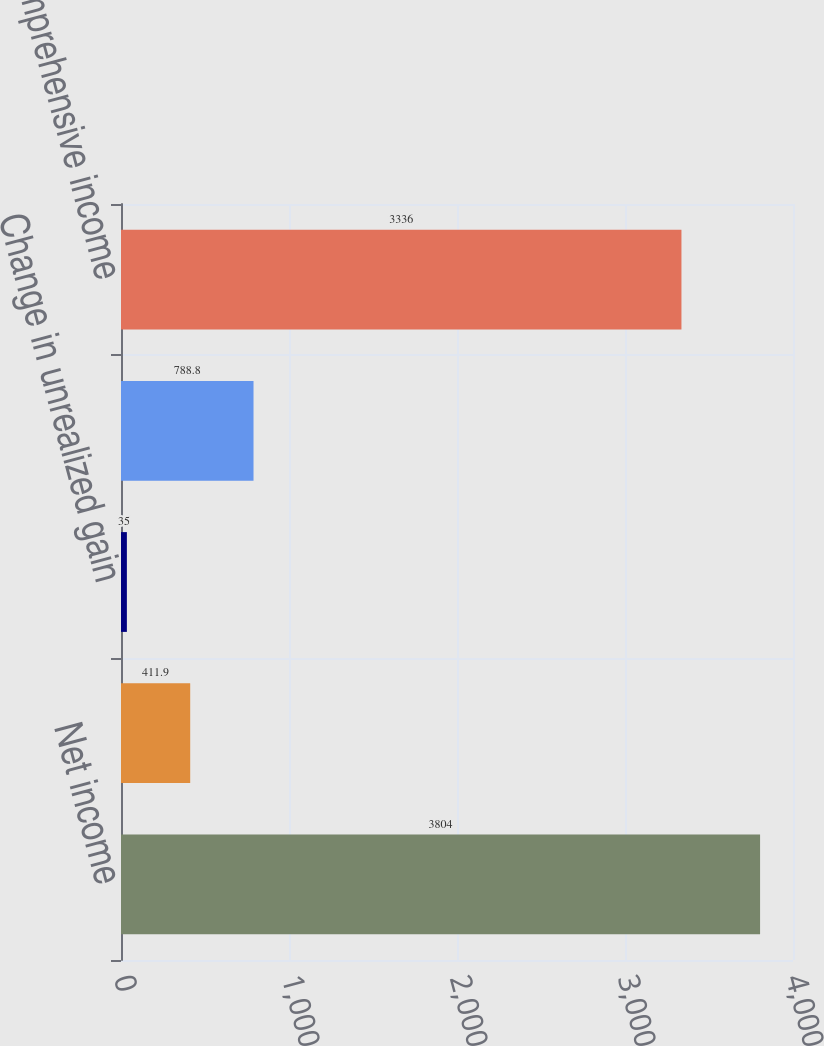Convert chart to OTSL. <chart><loc_0><loc_0><loc_500><loc_500><bar_chart><fcel>Net income<fcel>Change in foreign currency<fcel>Change in unrealized gain<fcel>Change in unrecognized pension<fcel>Comprehensive income<nl><fcel>3804<fcel>411.9<fcel>35<fcel>788.8<fcel>3336<nl></chart> 